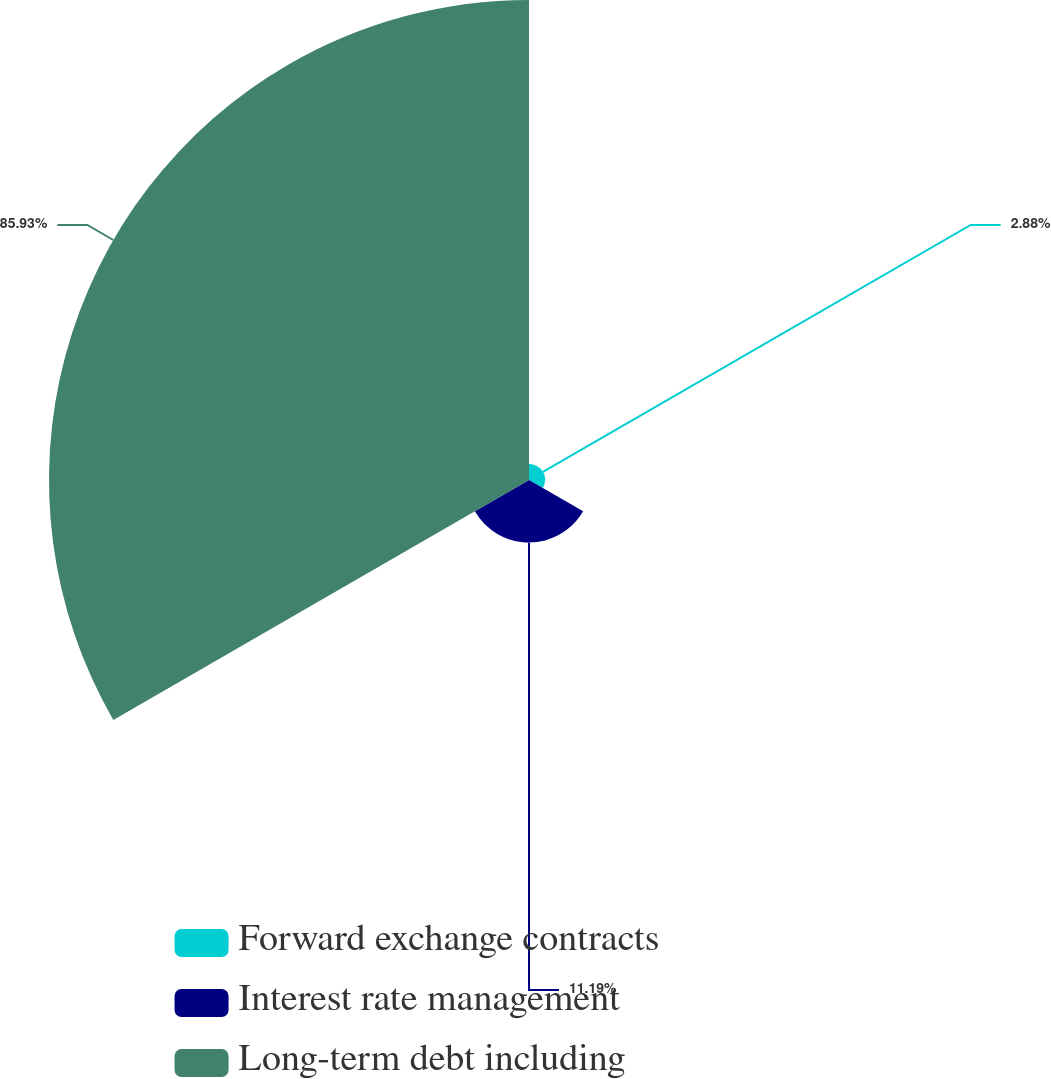<chart> <loc_0><loc_0><loc_500><loc_500><pie_chart><fcel>Forward exchange contracts<fcel>Interest rate management<fcel>Long-term debt including<nl><fcel>2.88%<fcel>11.19%<fcel>85.93%<nl></chart> 